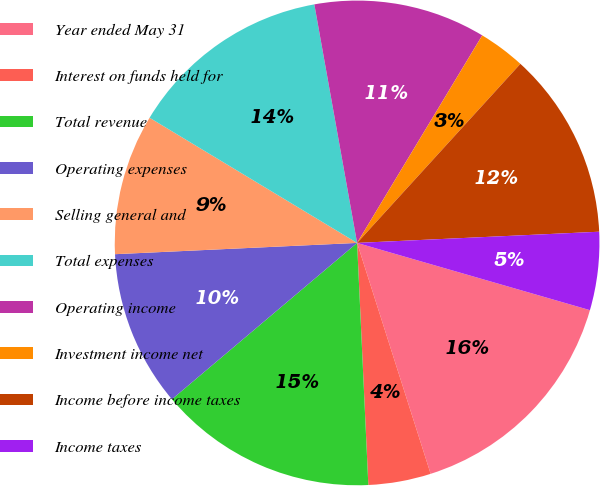Convert chart to OTSL. <chart><loc_0><loc_0><loc_500><loc_500><pie_chart><fcel>Year ended May 31<fcel>Interest on funds held for<fcel>Total revenue<fcel>Operating expenses<fcel>Selling general and<fcel>Total expenses<fcel>Operating income<fcel>Investment income net<fcel>Income before income taxes<fcel>Income taxes<nl><fcel>15.62%<fcel>4.17%<fcel>14.58%<fcel>10.42%<fcel>9.38%<fcel>13.54%<fcel>11.46%<fcel>3.13%<fcel>12.5%<fcel>5.21%<nl></chart> 